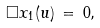Convert formula to latex. <formula><loc_0><loc_0><loc_500><loc_500>\Box { x } _ { 1 } ( u ) \, = \, 0 ,</formula> 